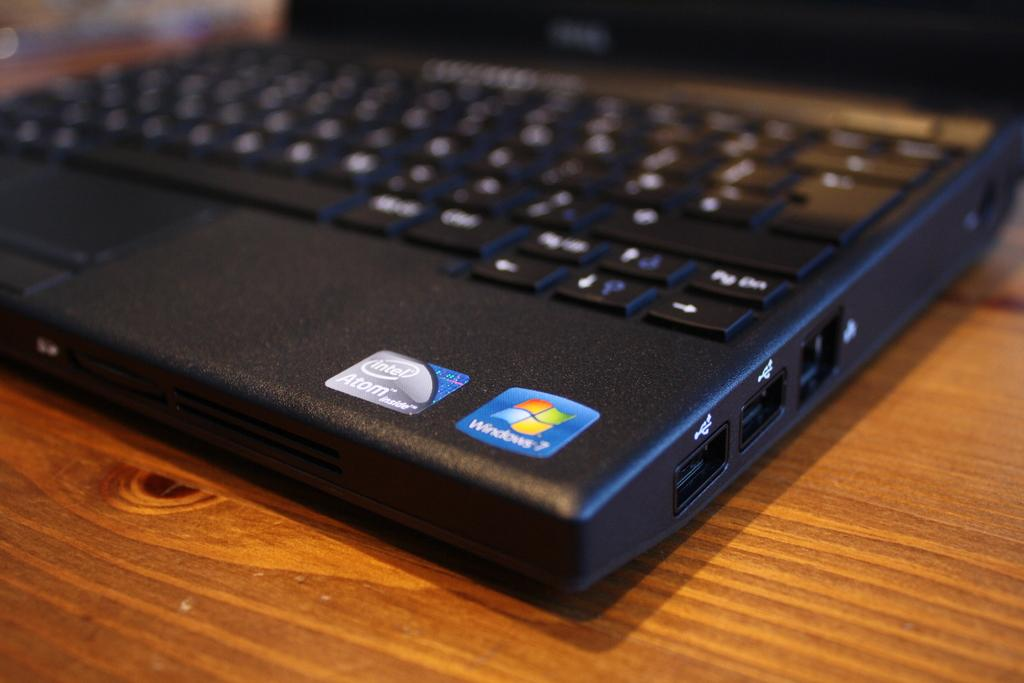Provide a one-sentence caption for the provided image. A black laptop has a colorful sticker that has a logo for Windows. 